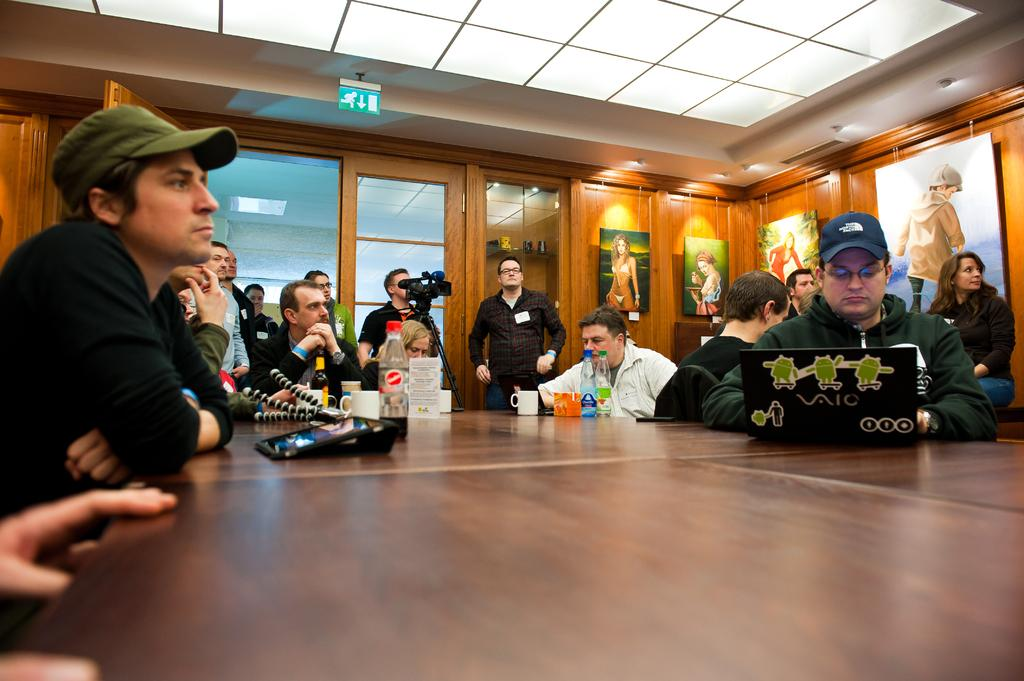What are the seated people doing in the image? There are people sitting on chairs in the image, and they are likely working or engaged in some activity. What object is in front of the seated people? There is a laptop in front of the seated people. What are the standing people doing in the image? The standing people are taking a video in the image. Can you describe the overall setting of the image? The image shows a group of people, some seated and some standing, with a laptop in front of the seated individuals. What type of underwear is the person in the image wearing? There is no information about the underwear of any person in the image, as the focus is on the seated and standing individuals and their activities. 